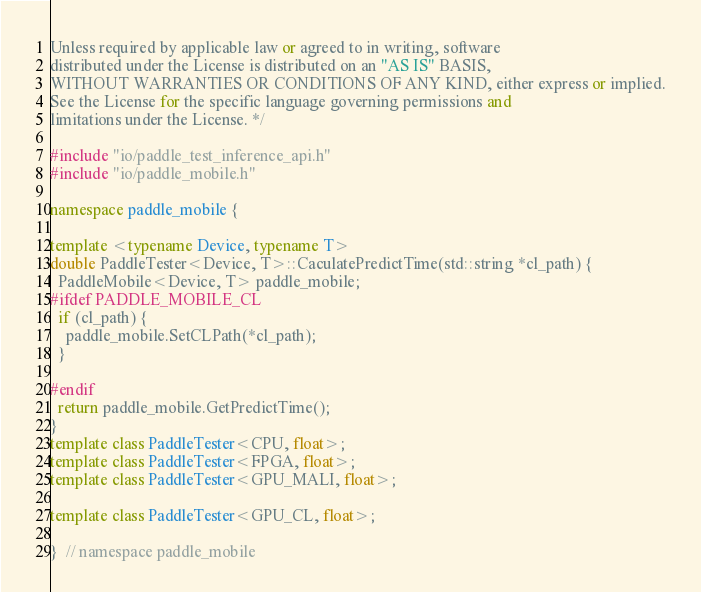Convert code to text. <code><loc_0><loc_0><loc_500><loc_500><_C++_>Unless required by applicable law or agreed to in writing, software
distributed under the License is distributed on an "AS IS" BASIS,
WITHOUT WARRANTIES OR CONDITIONS OF ANY KIND, either express or implied.
See the License for the specific language governing permissions and
limitations under the License. */

#include "io/paddle_test_inference_api.h"
#include "io/paddle_mobile.h"

namespace paddle_mobile {

template <typename Device, typename T>
double PaddleTester<Device, T>::CaculatePredictTime(std::string *cl_path) {
  PaddleMobile<Device, T> paddle_mobile;
#ifdef PADDLE_MOBILE_CL
  if (cl_path) {
    paddle_mobile.SetCLPath(*cl_path);
  }

#endif
  return paddle_mobile.GetPredictTime();
}
template class PaddleTester<CPU, float>;
template class PaddleTester<FPGA, float>;
template class PaddleTester<GPU_MALI, float>;

template class PaddleTester<GPU_CL, float>;

}  // namespace paddle_mobile
</code> 